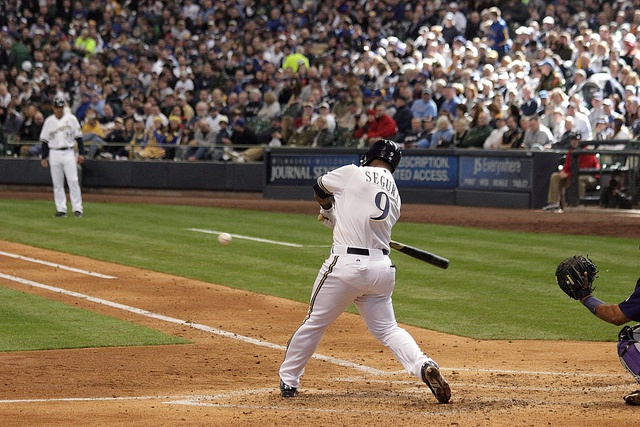Describe the objects in this image and their specific colors. I can see people in black, gray, darkgray, and maroon tones, people in black, lightgray, darkgray, and gray tones, people in black, lightgray, darkgray, and gray tones, baseball glove in black, gray, and darkgreen tones, and people in black, maroon, and gray tones in this image. 